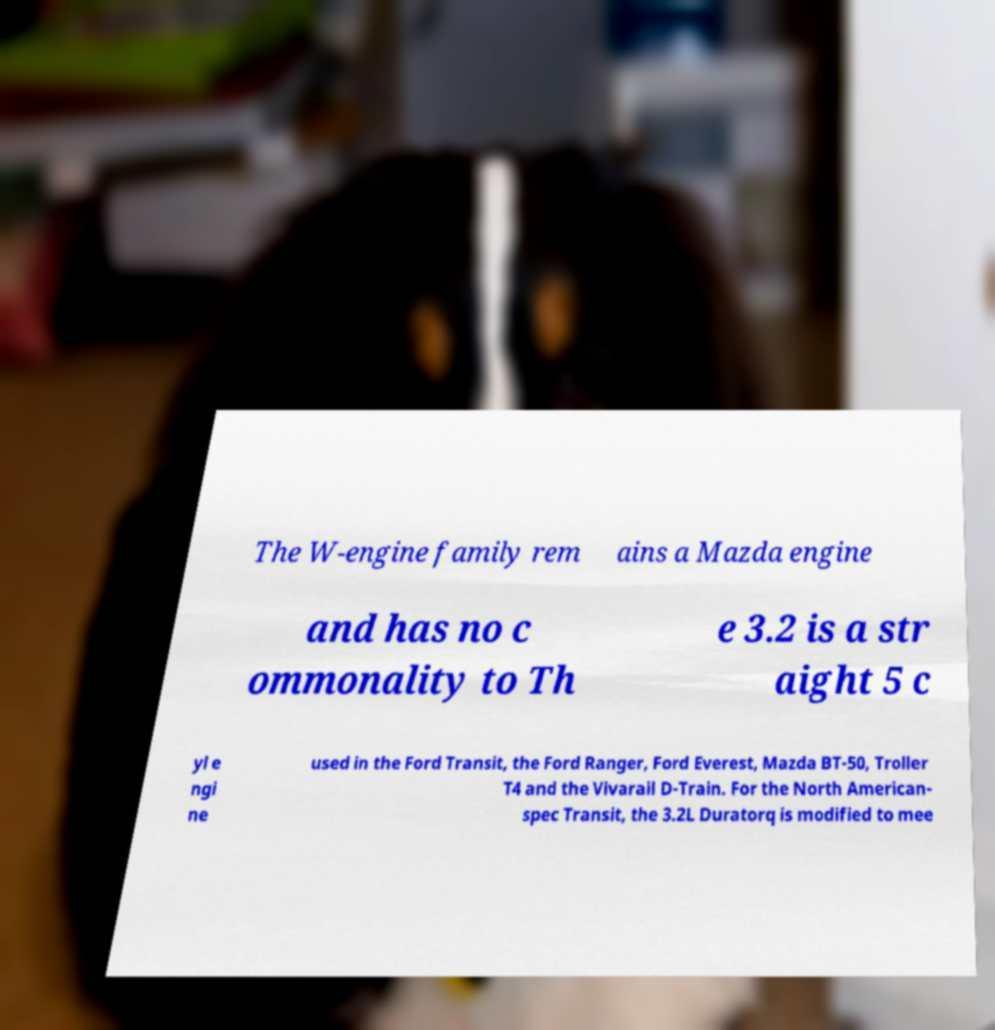I need the written content from this picture converted into text. Can you do that? The W-engine family rem ains a Mazda engine and has no c ommonality to Th e 3.2 is a str aight 5 c yl e ngi ne used in the Ford Transit, the Ford Ranger, Ford Everest, Mazda BT-50, Troller T4 and the Vivarail D-Train. For the North American- spec Transit, the 3.2L Duratorq is modified to mee 